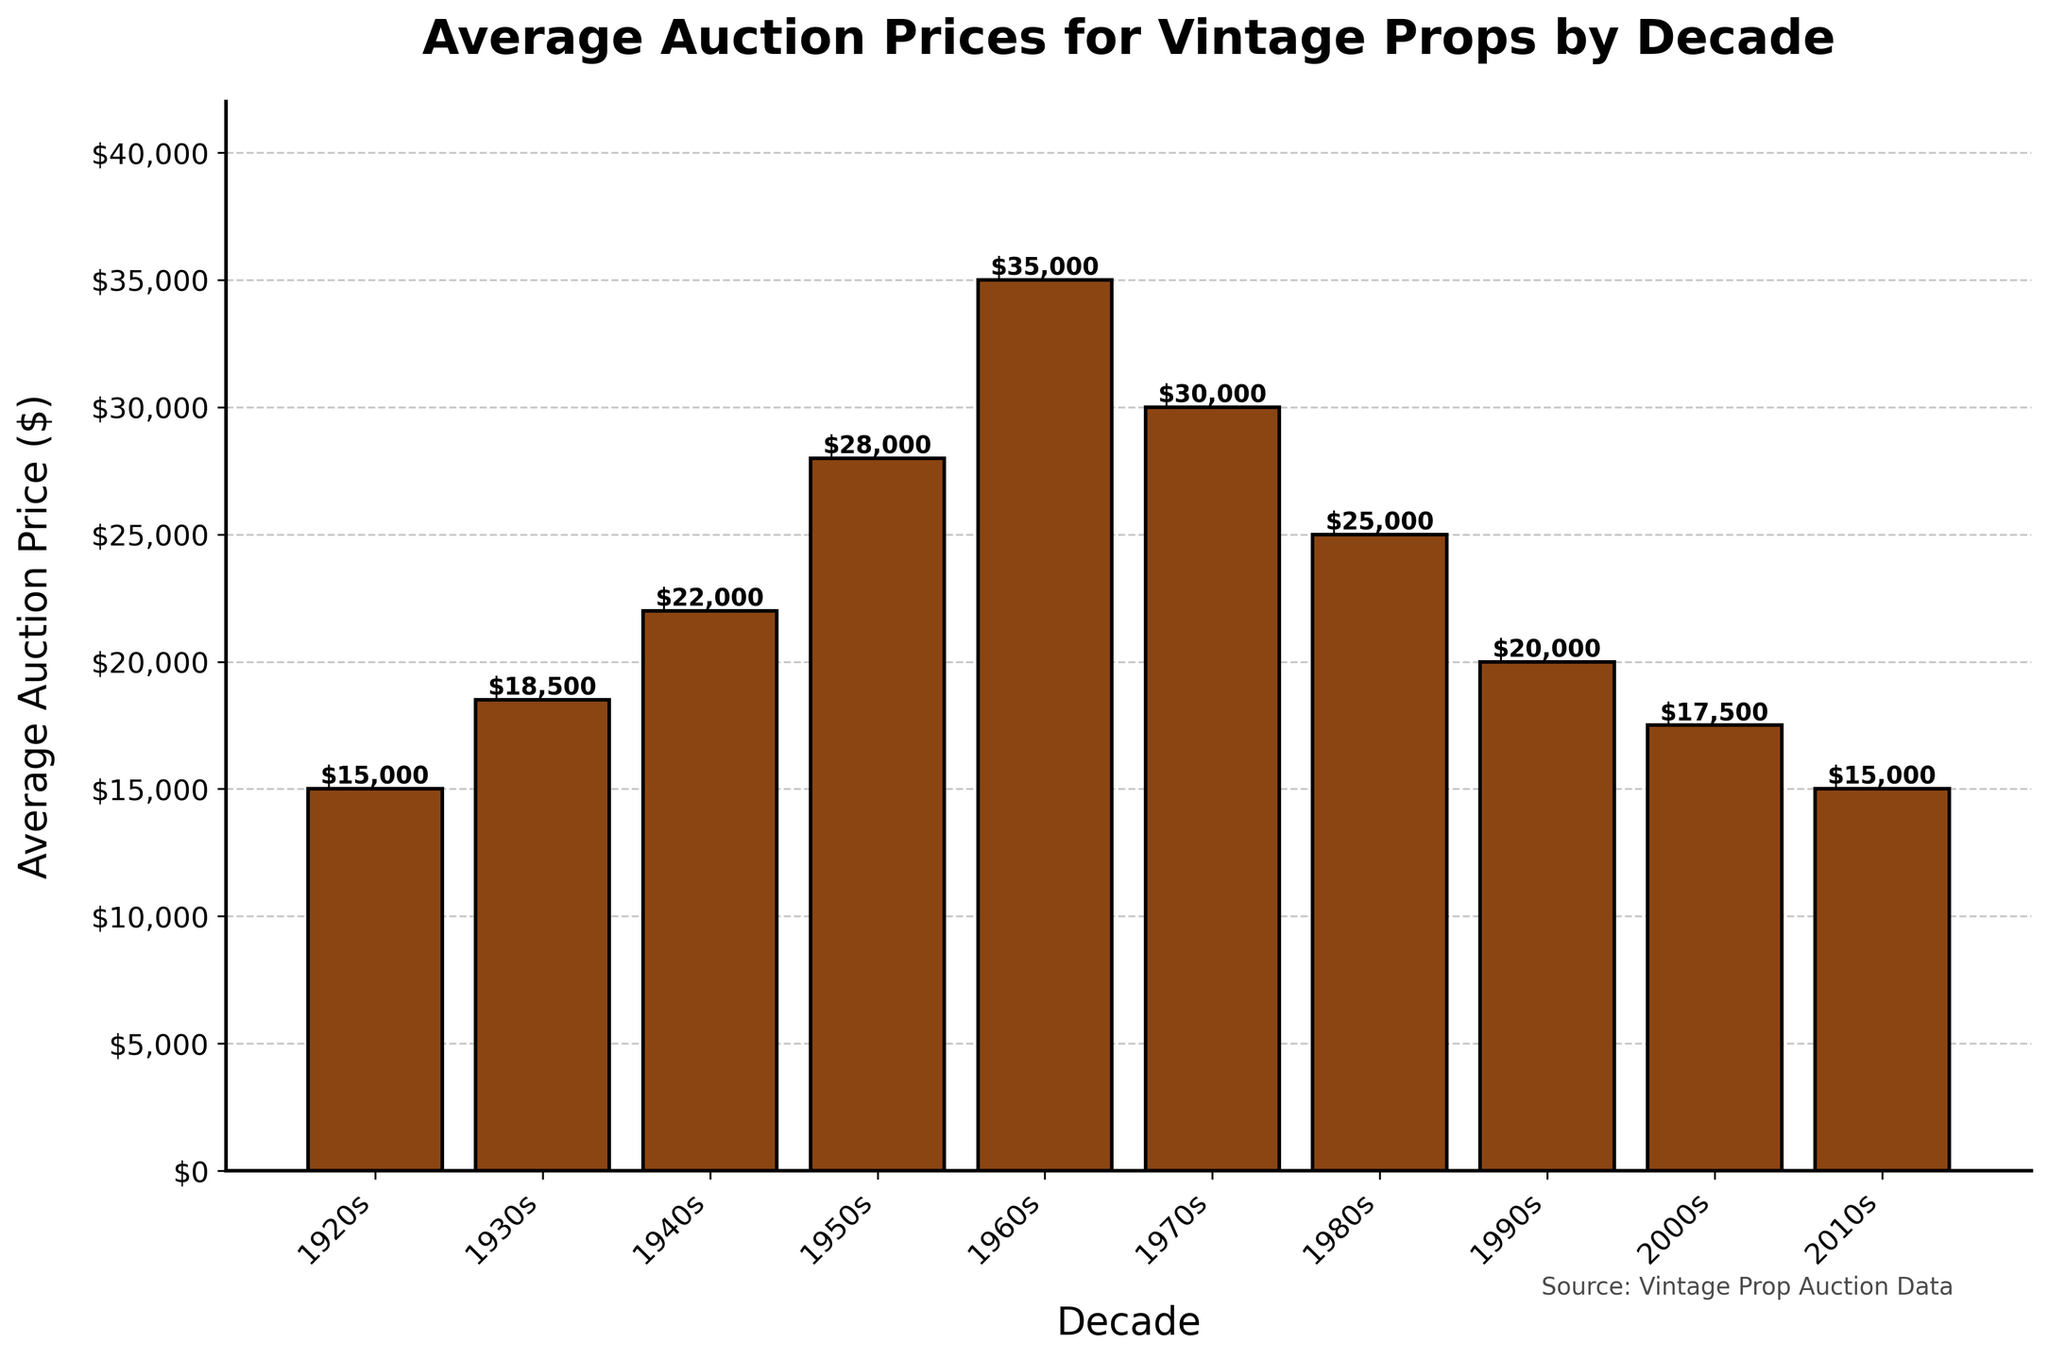What decade had the highest average auction price for vintage props? To find this, look at the bar with the greatest height. The highest bar represents the 1960s.
Answer: 1960s What is the difference in average auction prices between the 1950s and the 1980s? Subtract the average auction price of the 1980s from the average auction price of the 1950s: $28,000 - $25,000.
Answer: $3,000 Which decade experienced a higher average auction price: the 1970s or 1990s? Compare the heights of the bars representing these two decades. The 1970s have an average auction price of $30,000 vs. the 1990s which have $20,000.
Answer: 1970s What is the total average auction price for the decades from the 1920s to the 1960s? Sum the average auction prices for these decades: $15,000 (1920s) + $18,500 (1930s) + $22,000 (1940s) + $28,000 (1950s) + $35,000 (1960s) = $118,500.
Answer: $118,500 What is the average auction price per decade for the 1970s, 1980s, and 1990s combined? Sum the average auction prices for these decades and then divide by 3: ($30,000 + $25,000 + $20,000) / 3 = $25,000.
Answer: $25,000 How much lower is the average auction price for the 2010s compared to the 1960s? Subtract the average auction price of the 2010s from that of the 1960s: $35,000 - $15,000.
Answer: $20,000 Which two consecutive decades show the largest increase in average auction price? Calculate the difference between each pair of consecutive decades and identify the pair with the largest positive difference. The largest increase is between the 1950s ($28,000) and the 1960s ($35,000), which is $7,000.
Answer: 1950s to 1960s What is the average auction price for vintage props in the decades 2000s and 2010s? Sum the average auction prices for these two decades and divide by 2: ($17,500 + $15,000) / 2 = $16,250.
Answer: $16,250 